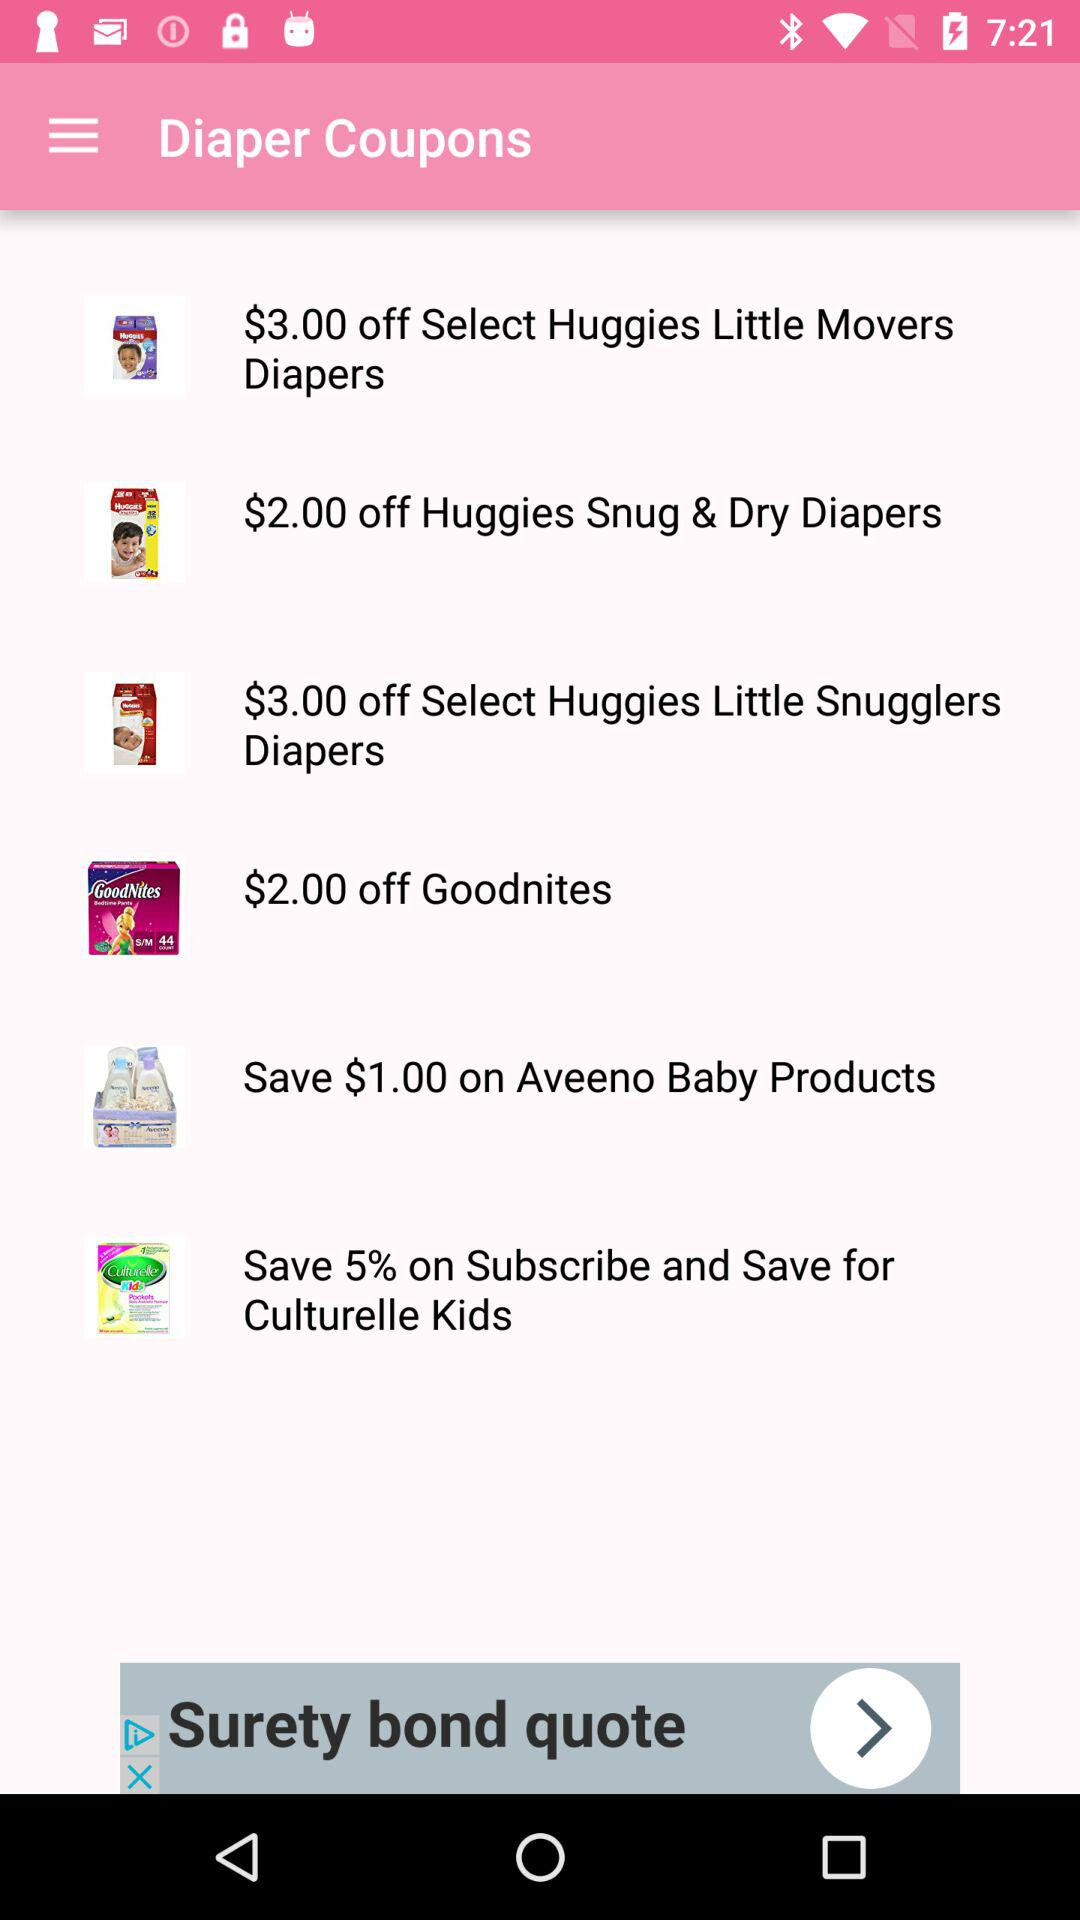What amount is off on "Huggies Snug & Dry Diapers"? There is an off of $2. 